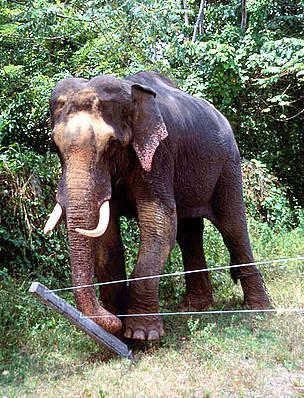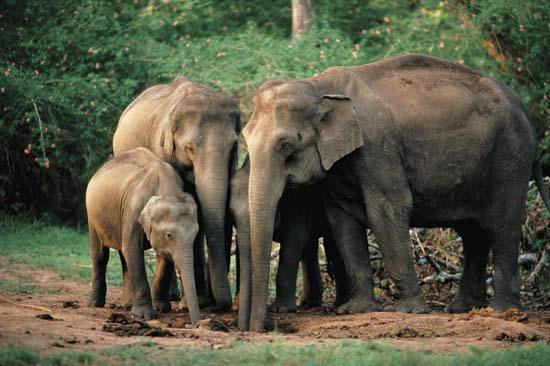The first image is the image on the left, the second image is the image on the right. For the images shown, is this caption "The right image shows just one baby elephant next to one adult." true? Answer yes or no. No. 